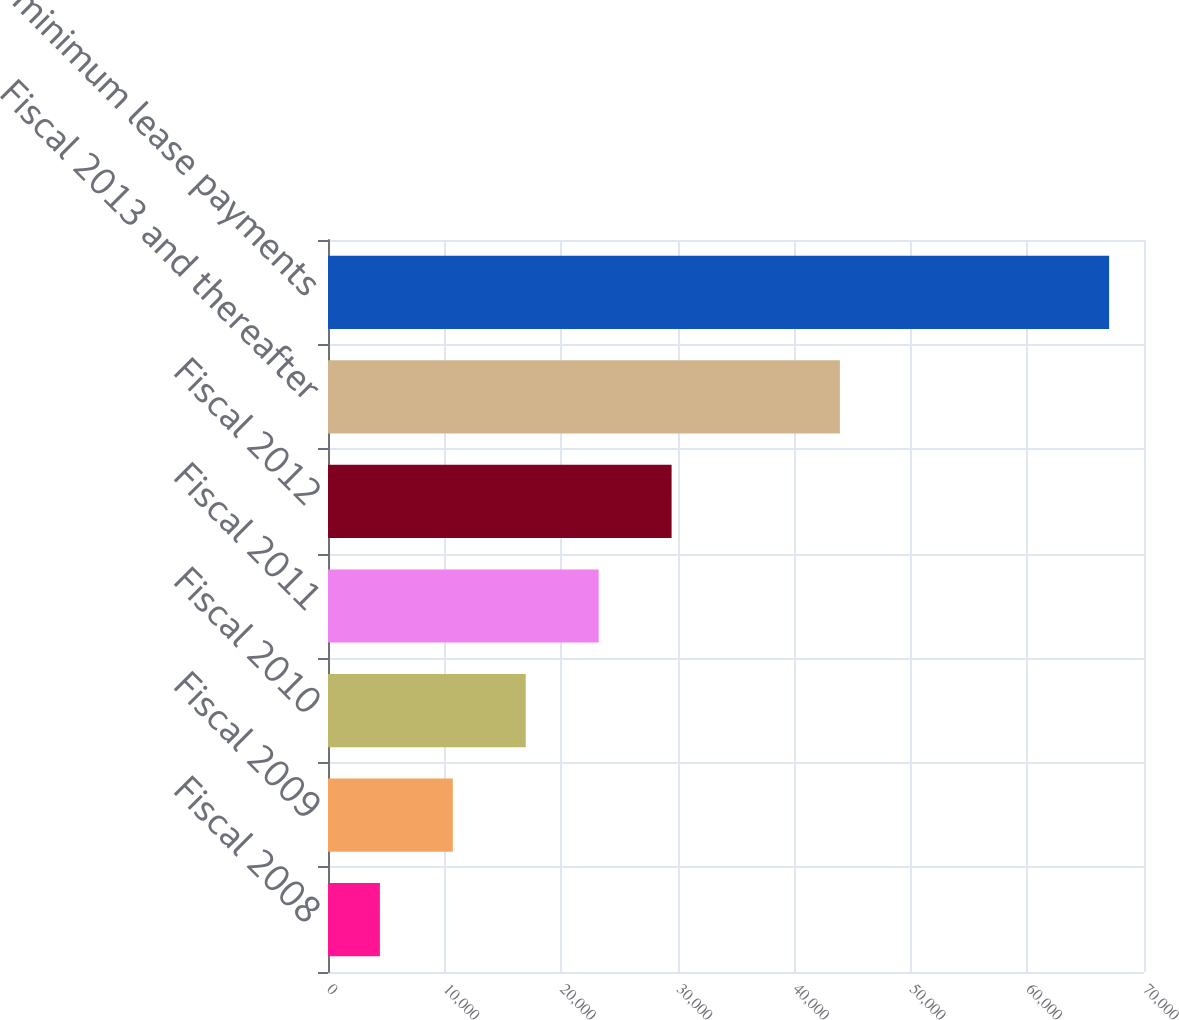<chart> <loc_0><loc_0><loc_500><loc_500><bar_chart><fcel>Fiscal 2008<fcel>Fiscal 2009<fcel>Fiscal 2010<fcel>Fiscal 2011<fcel>Fiscal 2012<fcel>Fiscal 2013 and thereafter<fcel>Total minimum lease payments<nl><fcel>4453<fcel>10708.7<fcel>16964.4<fcel>23220.1<fcel>29475.8<fcel>43914<fcel>67010<nl></chart> 